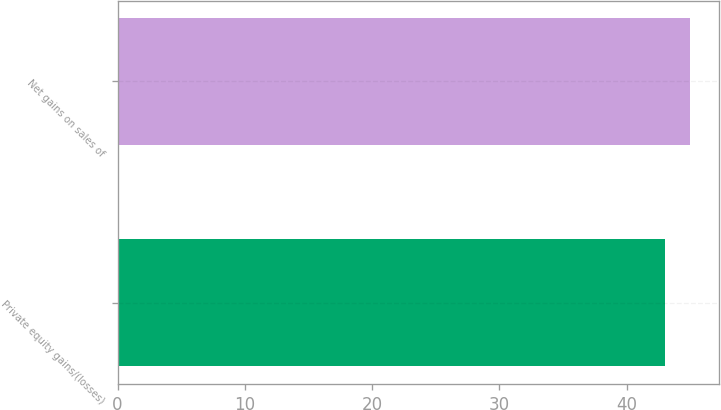Convert chart to OTSL. <chart><loc_0><loc_0><loc_500><loc_500><bar_chart><fcel>Private equity gains/(losses)<fcel>Net gains on sales of<nl><fcel>43<fcel>45<nl></chart> 